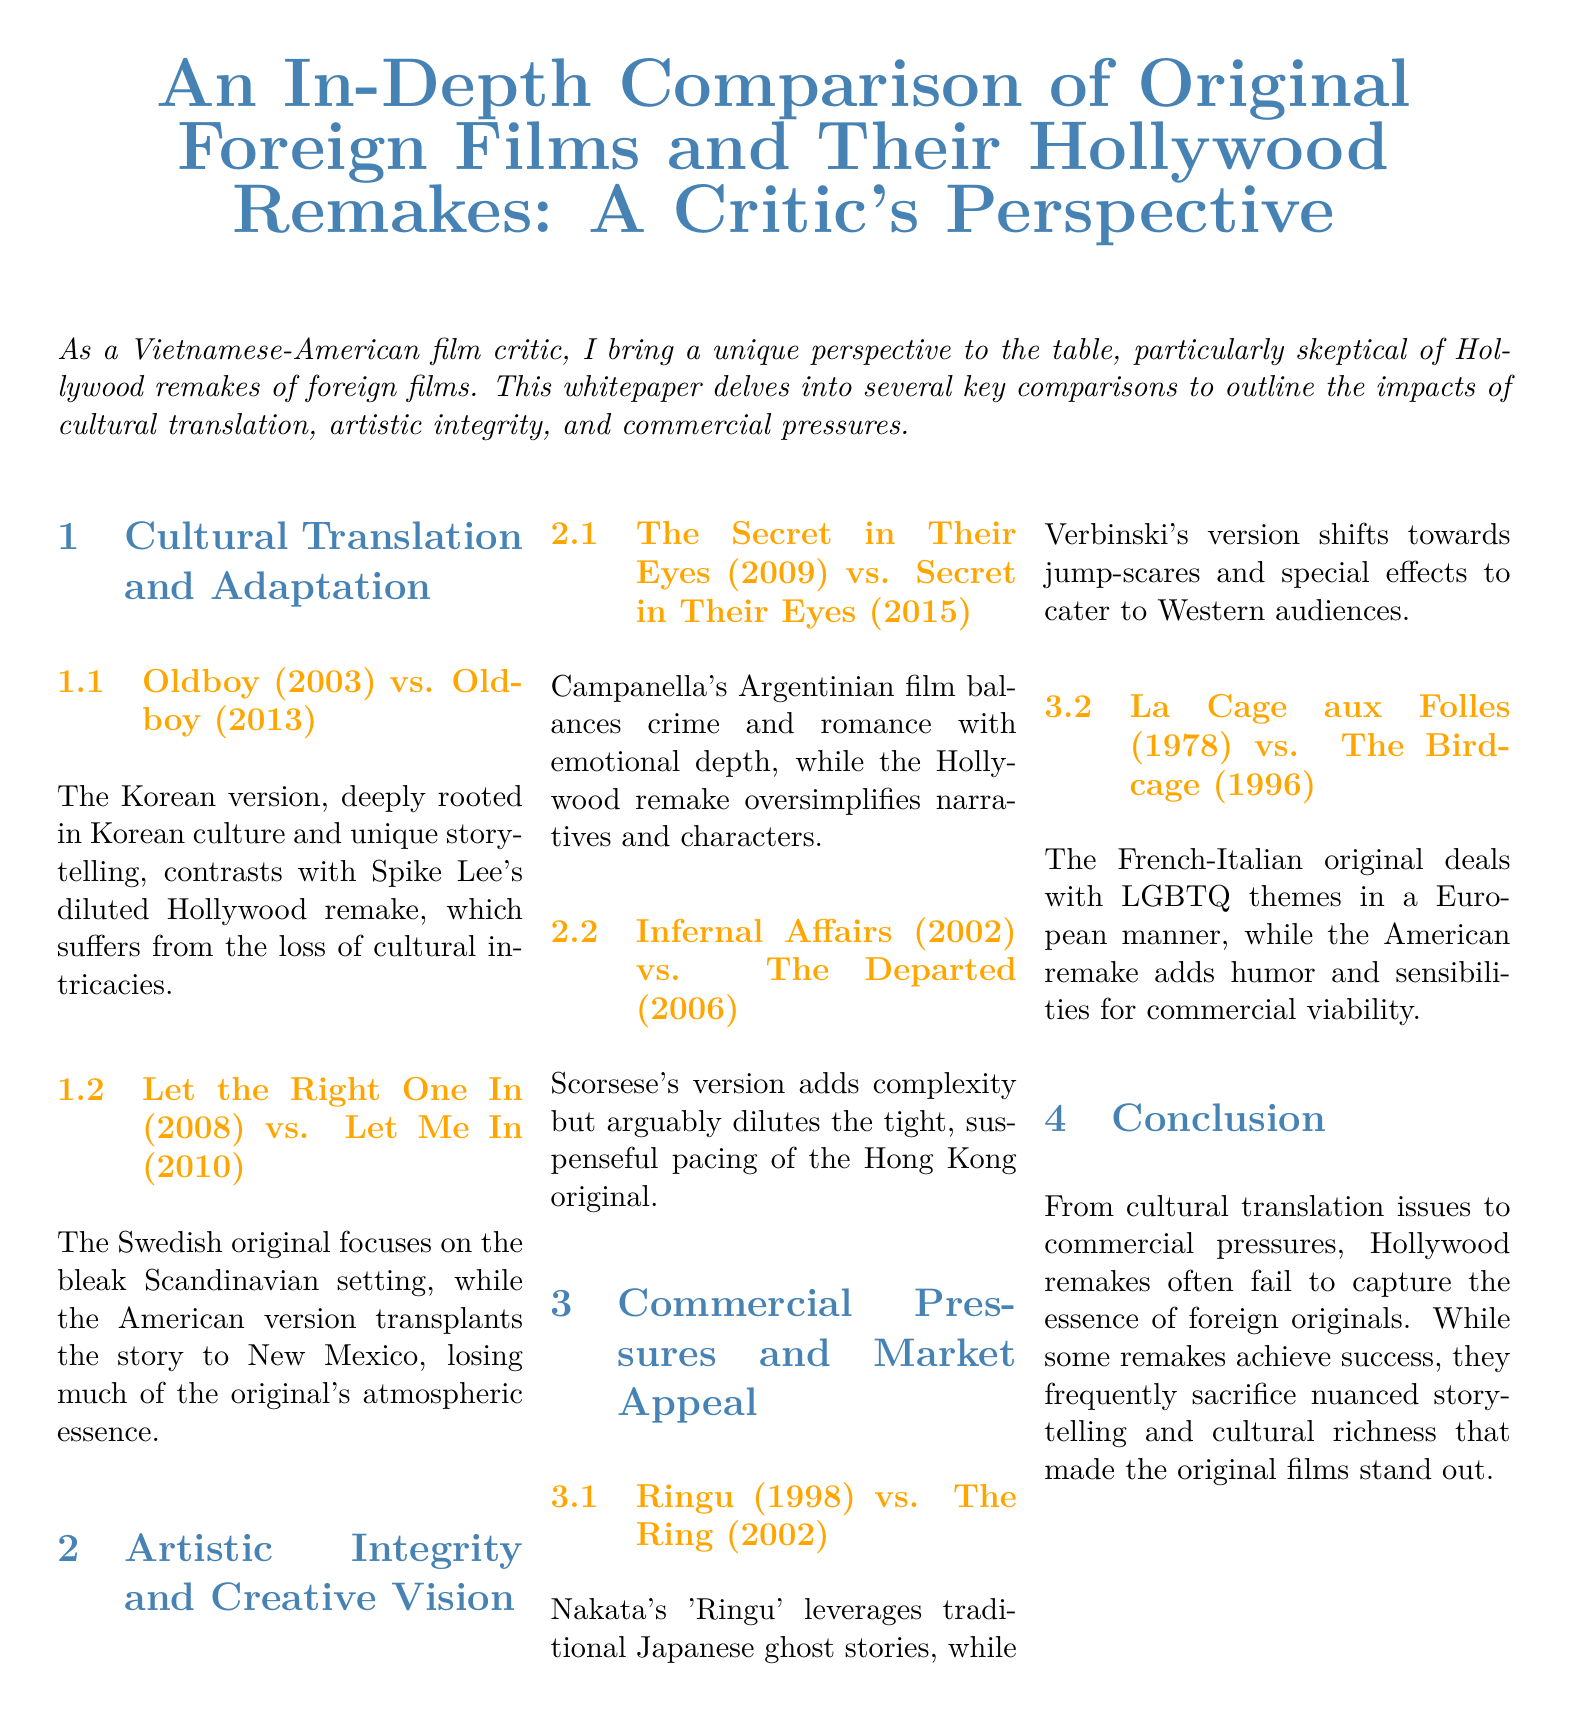What is the focus of the whitepaper? The whitepaper delves into key comparisons to outline the impacts of cultural translation, artistic integrity, and commercial pressures.
Answer: Cultural translation, artistic integrity, and commercial pressures What are the original and remake titles compared in the section on cultural translation? The original and remake titles compared are identified as "Oldboy" for the first example.
Answer: Oldboy Who directed the Hollywood remake of "Oldboy"? The document mentions Spike Lee as the director of the Hollywood remake.
Answer: Spike Lee In which year was the original "Let the Right One In" released? The release year can be found in the document as 2008.
Answer: 2008 What aspect does the section on commercial pressures address? The section on commercial pressures addresses how Hollywood remakes are influenced by market appeal and commercial viability.
Answer: Market appeal and commercial viability Which remake is associated with jump-scares and special effects? The Hollywood remake associated with jump-scares and special effects is "The Ring."
Answer: The Ring What additional elements does Scorsese's version of "Infernal Affairs" bring? The document indicates that Scorsese's version adds complexity, though it may dilute suspense.
Answer: Complexity What theme does "La Cage aux Folles" deal with in contrast to "The Birdcage"? The original title "La Cage aux Folles" deals with LGBTQ themes, which is emphasized in the comparison.
Answer: LGBTQ themes What is the consensus on Hollywood remakes presented in the conclusion? The conclusion discusses the tendency of remakes to fail to capture the essence of foreign originals due to various factors.
Answer: Fail to capture essence 